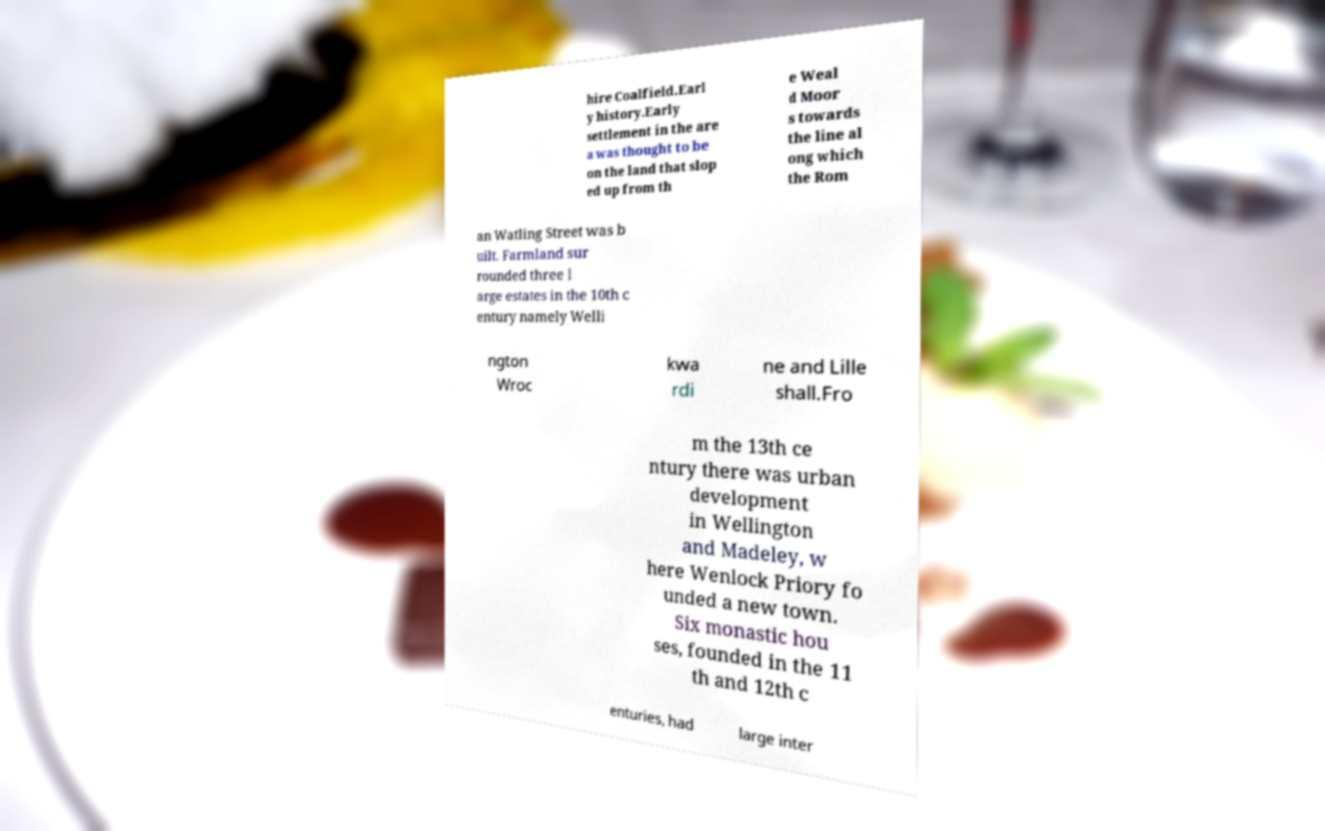Could you extract and type out the text from this image? hire Coalfield.Earl y history.Early settlement in the are a was thought to be on the land that slop ed up from th e Weal d Moor s towards the line al ong which the Rom an Watling Street was b uilt. Farmland sur rounded three l arge estates in the 10th c entury namely Welli ngton Wroc kwa rdi ne and Lille shall.Fro m the 13th ce ntury there was urban development in Wellington and Madeley, w here Wenlock Priory fo unded a new town. Six monastic hou ses, founded in the 11 th and 12th c enturies, had large inter 